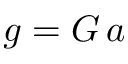Convert formula to latex. <formula><loc_0><loc_0><loc_500><loc_500>g = G \, a</formula> 